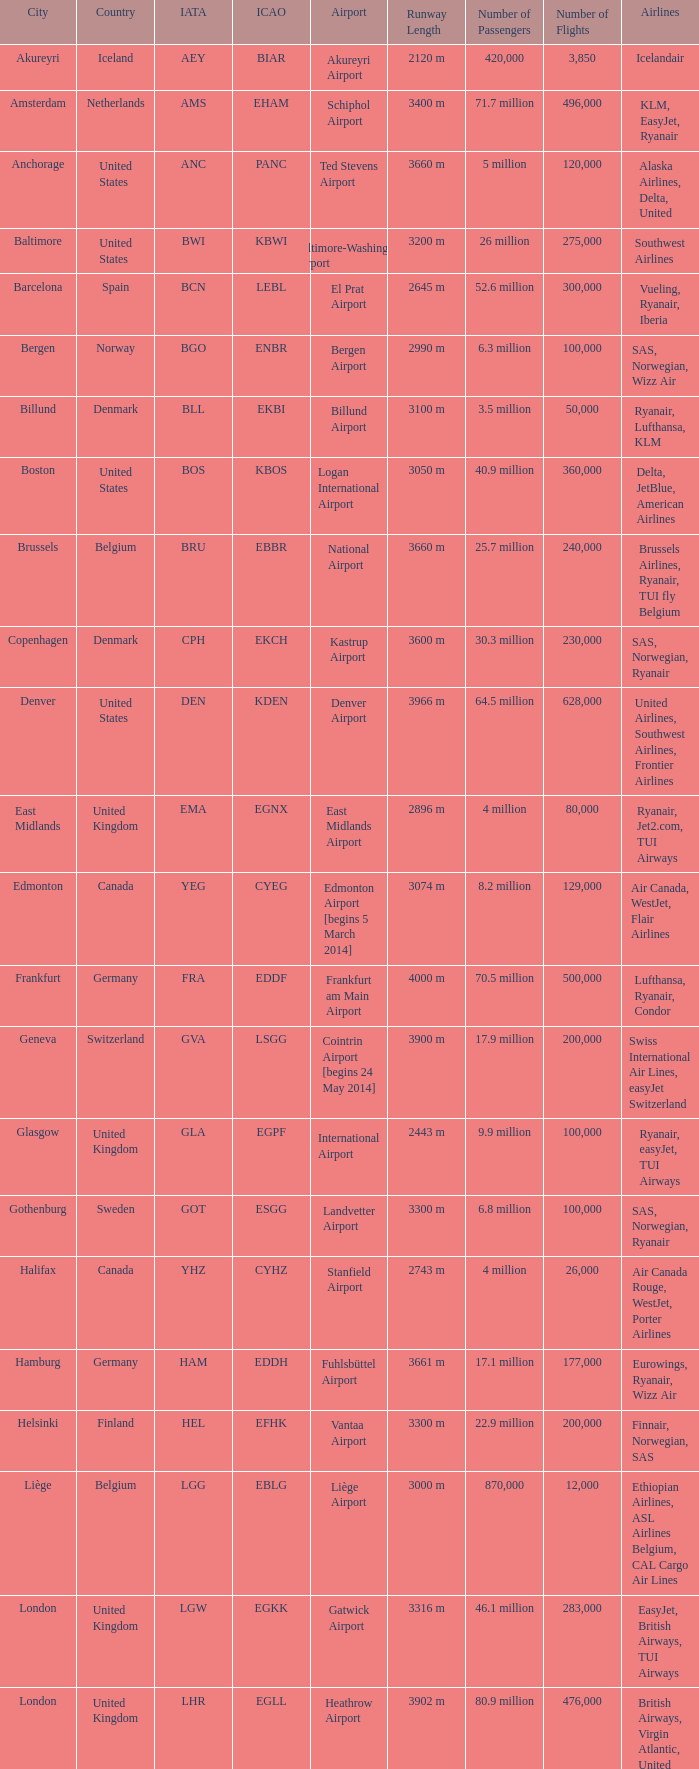What is the Airport with a ICAO of EDDH? Fuhlsbüttel Airport. 